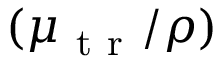<formula> <loc_0><loc_0><loc_500><loc_500>( \mu _ { t r } / \rho )</formula> 